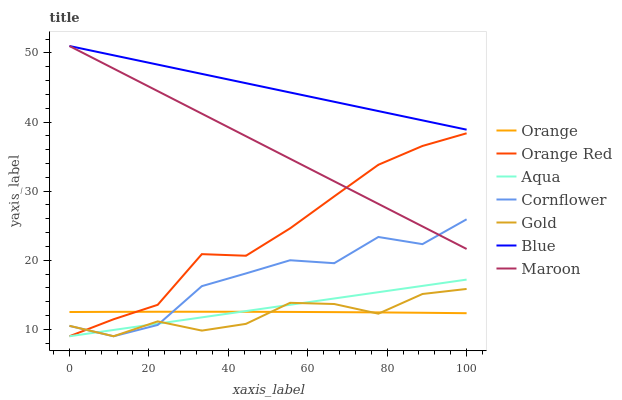Does Gold have the minimum area under the curve?
Answer yes or no. Yes. Does Blue have the maximum area under the curve?
Answer yes or no. Yes. Does Cornflower have the minimum area under the curve?
Answer yes or no. No. Does Cornflower have the maximum area under the curve?
Answer yes or no. No. Is Aqua the smoothest?
Answer yes or no. Yes. Is Cornflower the roughest?
Answer yes or no. Yes. Is Gold the smoothest?
Answer yes or no. No. Is Gold the roughest?
Answer yes or no. No. Does Cornflower have the lowest value?
Answer yes or no. Yes. Does Maroon have the lowest value?
Answer yes or no. No. Does Maroon have the highest value?
Answer yes or no. Yes. Does Cornflower have the highest value?
Answer yes or no. No. Is Cornflower less than Blue?
Answer yes or no. Yes. Is Blue greater than Cornflower?
Answer yes or no. Yes. Does Orange intersect Orange Red?
Answer yes or no. Yes. Is Orange less than Orange Red?
Answer yes or no. No. Is Orange greater than Orange Red?
Answer yes or no. No. Does Cornflower intersect Blue?
Answer yes or no. No. 